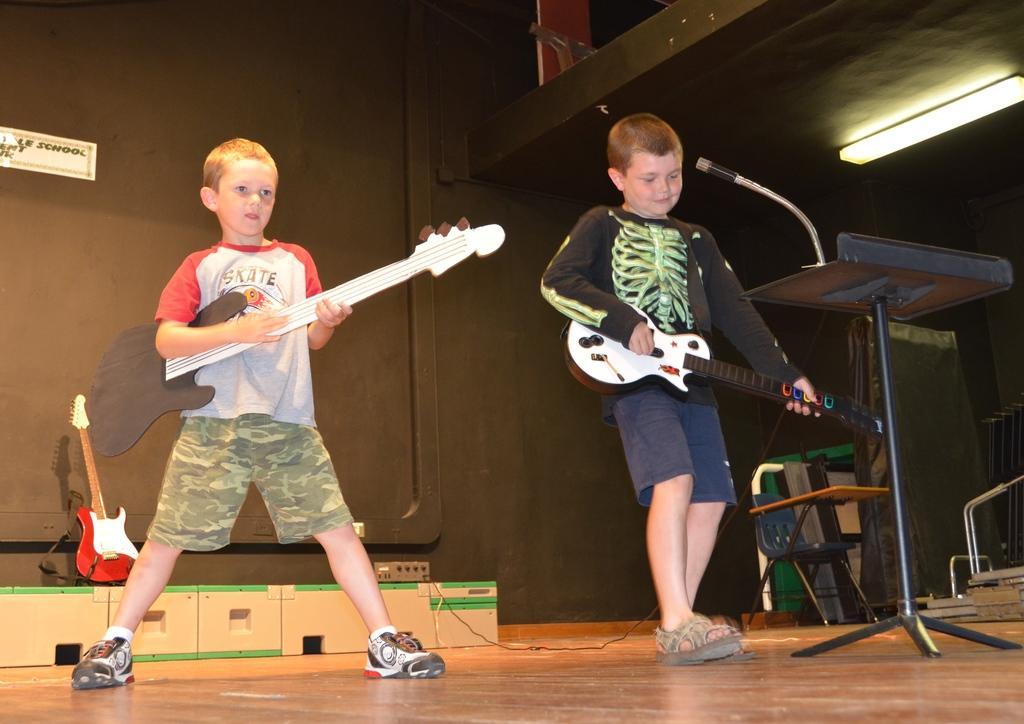Describe this image in one or two sentences. In this image there are two boys who are standing and they are holding guitar. On the right side there is one board and one mike is there. On the top there is a wall and on the bottom of the left corner there is one table and on that table there is another guitar and on the top of the right corner there is one light. 